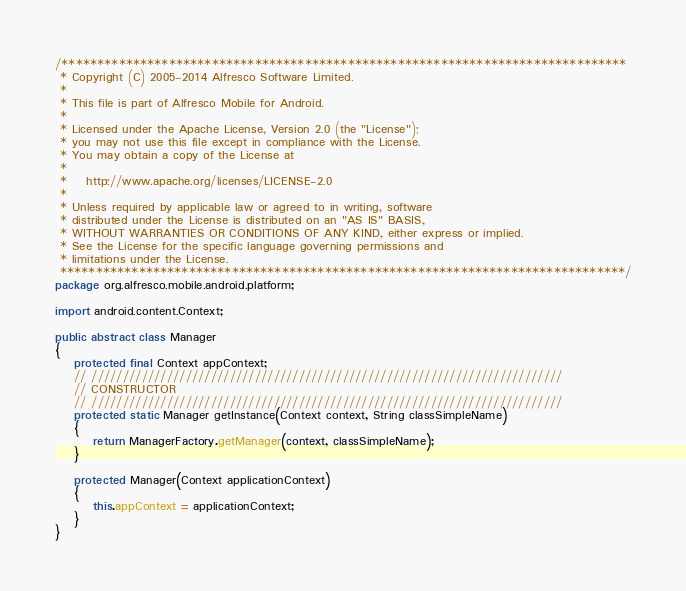Convert code to text. <code><loc_0><loc_0><loc_500><loc_500><_Java_>/*******************************************************************************
 * Copyright (C) 2005-2014 Alfresco Software Limited.
 *
 * This file is part of Alfresco Mobile for Android.
 *
 * Licensed under the Apache License, Version 2.0 (the "License");
 * you may not use this file except in compliance with the License.
 * You may obtain a copy of the License at
 *
 *    http://www.apache.org/licenses/LICENSE-2.0
 *
 * Unless required by applicable law or agreed to in writing, software
 * distributed under the License is distributed on an "AS IS" BASIS,
 * WITHOUT WARRANTIES OR CONDITIONS OF ANY KIND, either express or implied.
 * See the License for the specific language governing permissions and
 * limitations under the License.
 *******************************************************************************/
package org.alfresco.mobile.android.platform;

import android.content.Context;

public abstract class Manager
{
    protected final Context appContext;
    // ///////////////////////////////////////////////////////////////////////////
    // CONSTRUCTOR
    // ///////////////////////////////////////////////////////////////////////////
    protected static Manager getInstance(Context context, String classSimpleName)
    {
        return ManagerFactory.getManager(context, classSimpleName);
    }

    protected Manager(Context applicationContext)
    {
        this.appContext = applicationContext;
    }
}
</code> 